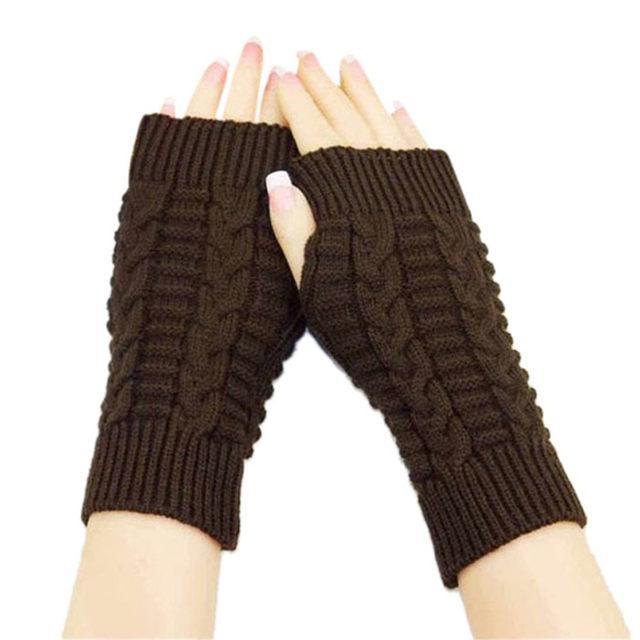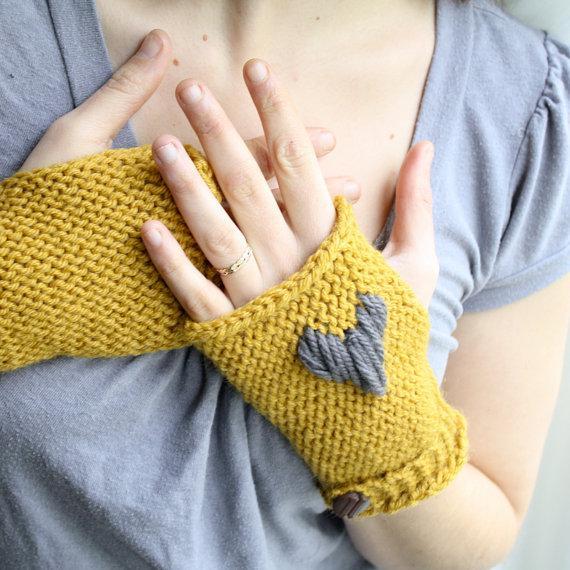The first image is the image on the left, the second image is the image on the right. Examine the images to the left and right. Is the description "The left and right image contains the same number of sets of fingerless mittens." accurate? Answer yes or no. Yes. 